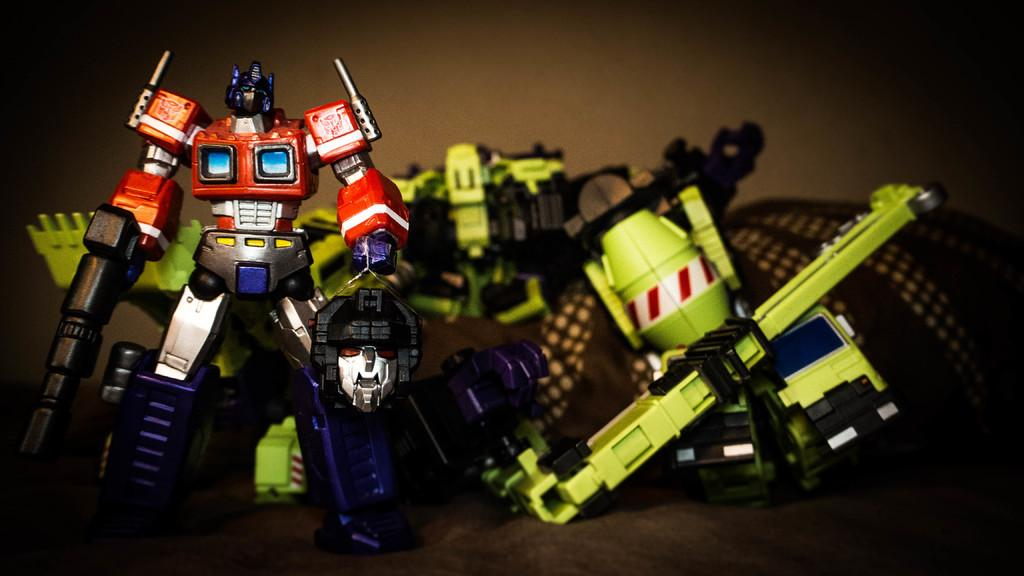What is the main subject of the image? The main subject of the image is toys. Where are the toys located in the image? The toys are in the center of the image. Can you tell me how many tigers are playing with the toys in the image? There are no tigers present in the image; it only features toys. What type of woman is coaching the children playing with the toys in the image? There is no woman or children present in the image; it only features toys. 